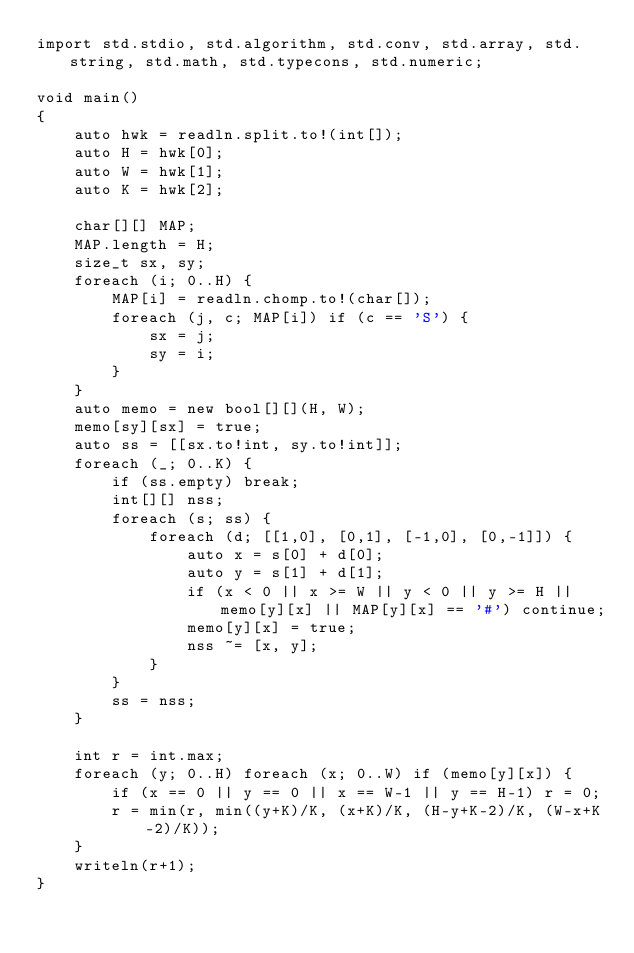<code> <loc_0><loc_0><loc_500><loc_500><_D_>import std.stdio, std.algorithm, std.conv, std.array, std.string, std.math, std.typecons, std.numeric;

void main()
{
    auto hwk = readln.split.to!(int[]);
    auto H = hwk[0];
    auto W = hwk[1];
    auto K = hwk[2];

    char[][] MAP;
    MAP.length = H;
    size_t sx, sy;
    foreach (i; 0..H) {
        MAP[i] = readln.chomp.to!(char[]);
        foreach (j, c; MAP[i]) if (c == 'S') {
            sx = j;
            sy = i;
        }
    }
    auto memo = new bool[][](H, W);
    memo[sy][sx] = true;
    auto ss = [[sx.to!int, sy.to!int]];
    foreach (_; 0..K) {
        if (ss.empty) break;
        int[][] nss;
        foreach (s; ss) {
            foreach (d; [[1,0], [0,1], [-1,0], [0,-1]]) {
                auto x = s[0] + d[0];
                auto y = s[1] + d[1];
                if (x < 0 || x >= W || y < 0 || y >= H || memo[y][x] || MAP[y][x] == '#') continue;
                memo[y][x] = true;
                nss ~= [x, y];
            }
        }
        ss = nss;
    }

    int r = int.max;
    foreach (y; 0..H) foreach (x; 0..W) if (memo[y][x]) {
        if (x == 0 || y == 0 || x == W-1 || y == H-1) r = 0;
        r = min(r, min((y+K)/K, (x+K)/K, (H-y+K-2)/K, (W-x+K-2)/K));
    }
    writeln(r+1);
}</code> 